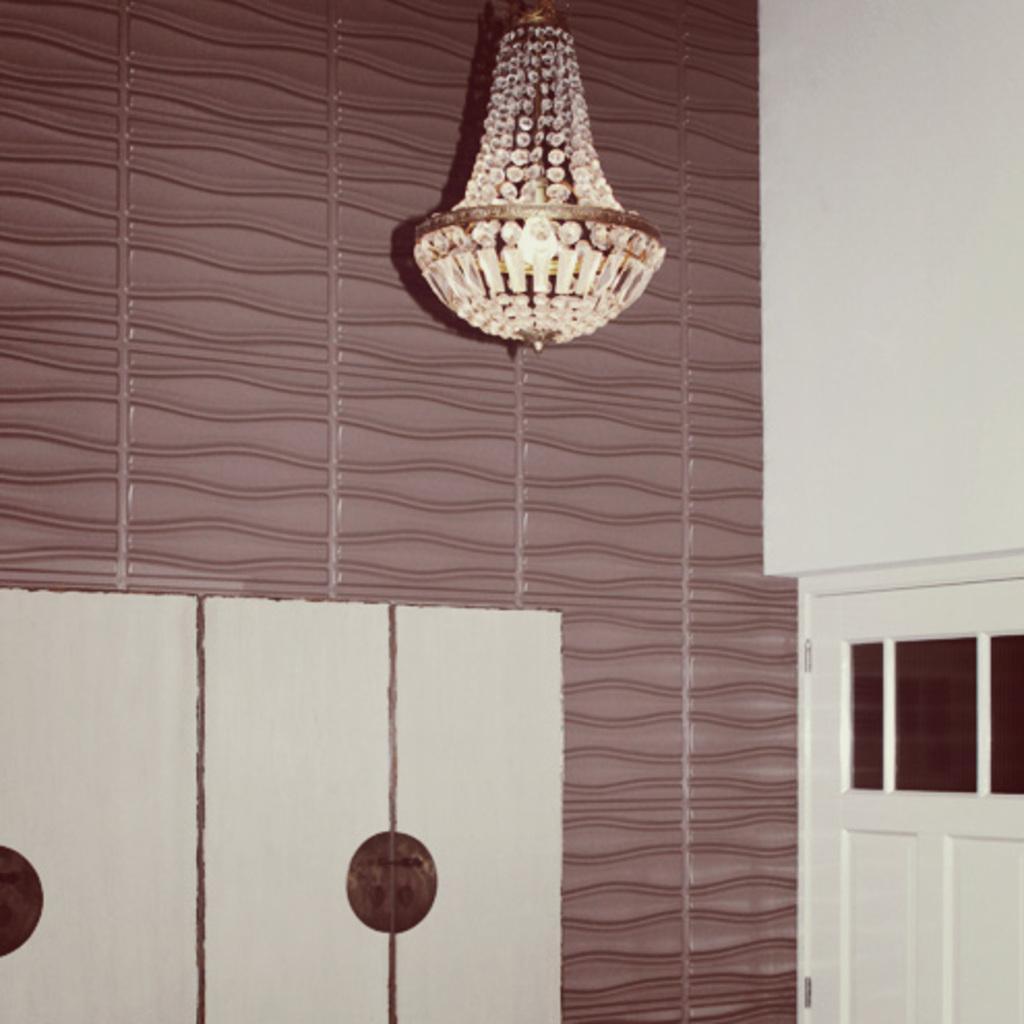Could you give a brief overview of what you see in this image? In this picture we can see a door, chandelier and in the background we can see a design wall. 